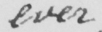Please provide the text content of this handwritten line. ever 